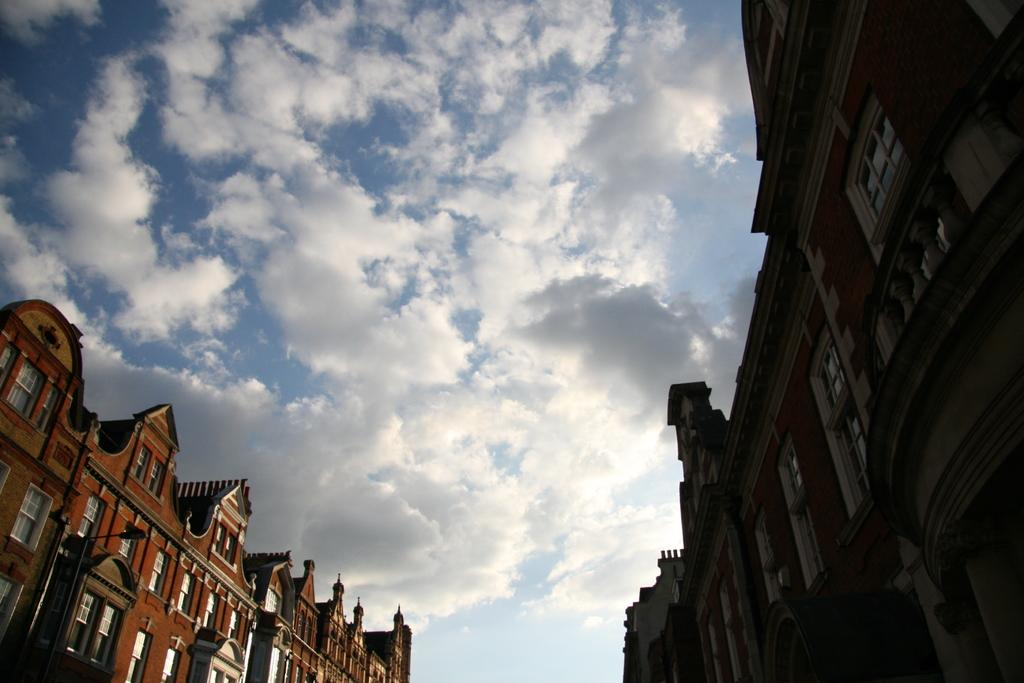Where was the image taken? The image was clicked outside. What types of structures can be seen in the image? There are buildings at the bottom and middle of the image. What part of the natural environment is visible in the image? The sky is visible at the top of the image. What type of coal can be seen in the image? There is no coal present in the image. What scent is associated with the image? The image does not have a scent, as it is a visual representation. 